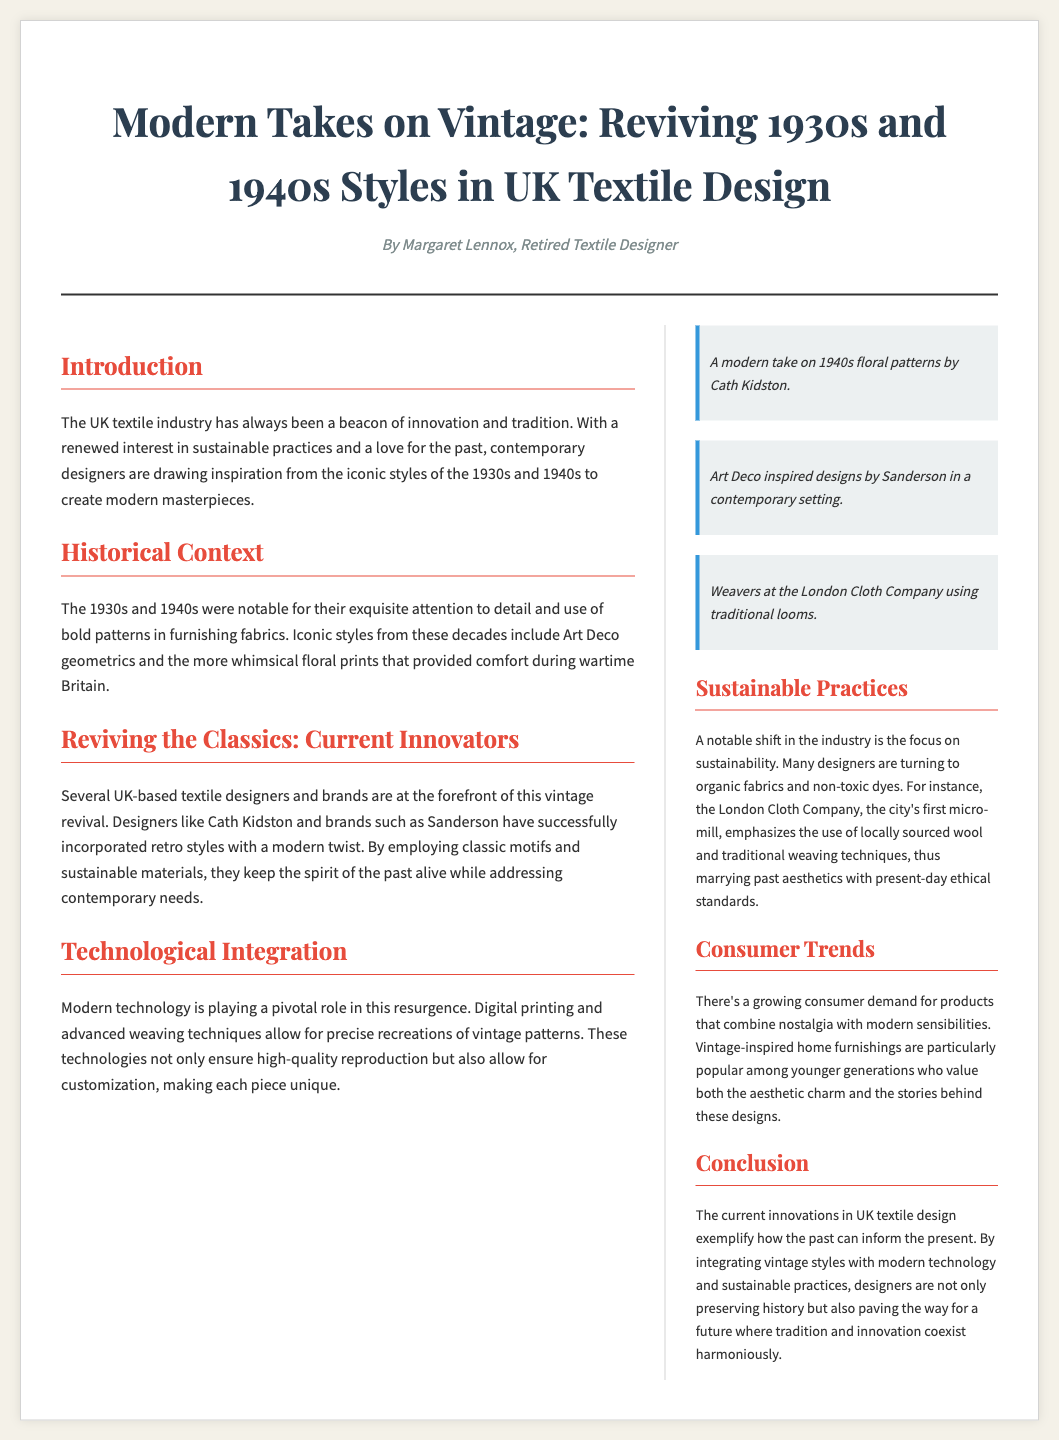what is the title of the article? The title appears prominently at the top of the document, offering insight into the theme of the article.
Answer: Modern Takes on Vintage: Reviving 1930s and 1940s Styles in UK Textile Design who is the author of the article? The byline below the title identifies the author of the piece, providing a personal touch to the article.
Answer: Margaret Lennox which two decades are primarily referenced for their textile styles? The introduction and historical context sections indicate the decades that inspired the modern designs mentioned in the article.
Answer: 1930s and 1940s what is a name of a designer mentioned in the article? The section on current innovators lists several designers that are part of the vintage revival in textile design.
Answer: Cath Kidston what technique is noted for allowing precise recreations of vintage patterns? The technological integration section highlights a specific modern method utilized in fabric design that has historical roots.
Answer: Digital printing which company emphasizes sustainability and traditional techniques in its practices? In the sustainable practices section, one specific company is highlighted for its commitment to environmentally friendly methods and traditional craftsmanship.
Answer: London Cloth Company what is a consumer trend mentioned in the article? The section on consumer trends discusses specific preferences observed among buyers in relation to vintage-inspired designs.
Answer: Nostalgia what color is predominantly associated with the heading of the sections? The design utilizes a specific color for the section headings, making them visually distinct within the layout.
Answer: Red 